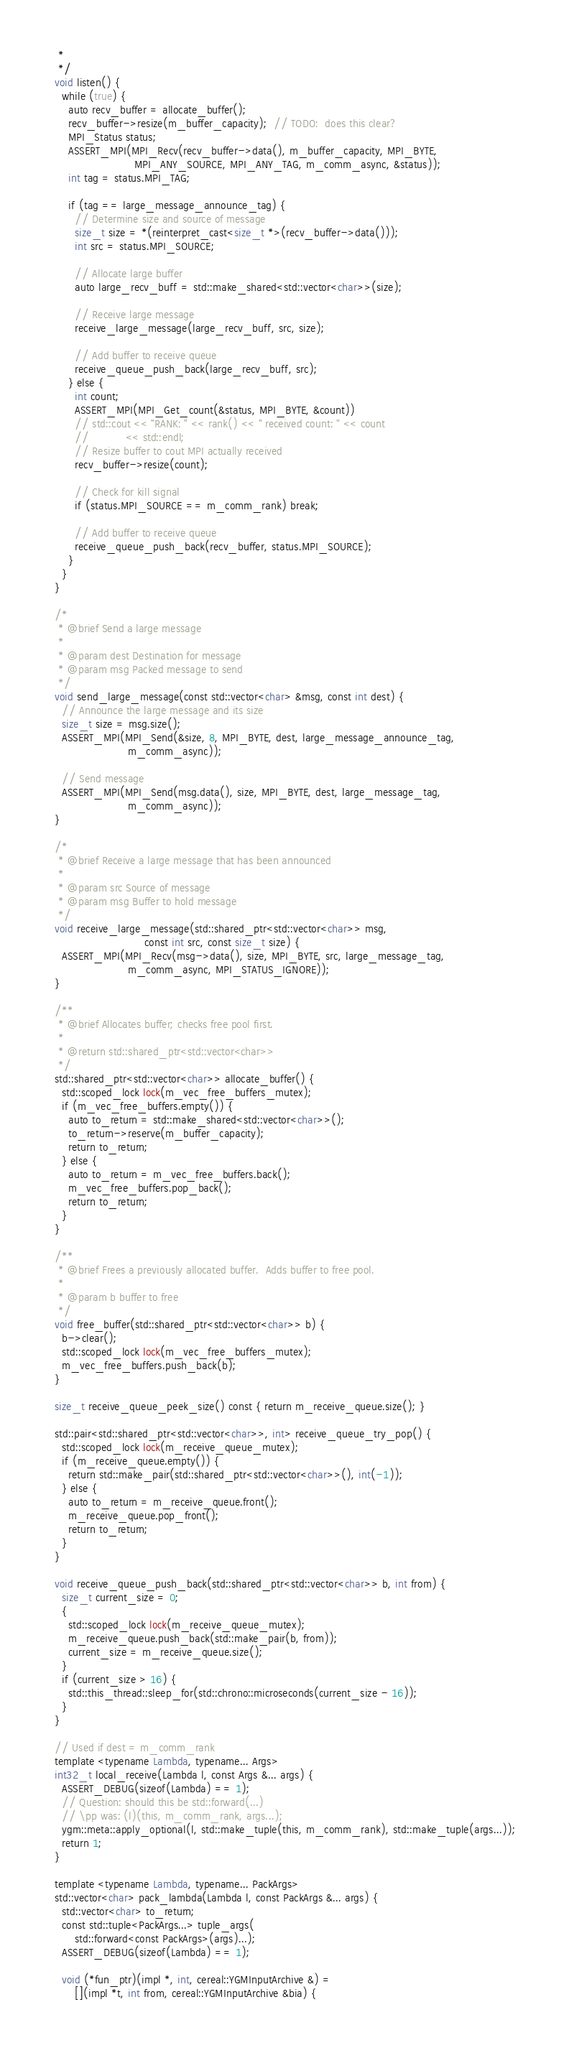<code> <loc_0><loc_0><loc_500><loc_500><_C++_>   *
   */
  void listen() {
    while (true) {
      auto recv_buffer = allocate_buffer();
      recv_buffer->resize(m_buffer_capacity);  // TODO:  does this clear?
      MPI_Status status;
      ASSERT_MPI(MPI_Recv(recv_buffer->data(), m_buffer_capacity, MPI_BYTE,
                          MPI_ANY_SOURCE, MPI_ANY_TAG, m_comm_async, &status));
      int tag = status.MPI_TAG;

      if (tag == large_message_announce_tag) {
        // Determine size and source of message
        size_t size = *(reinterpret_cast<size_t *>(recv_buffer->data()));
        int src = status.MPI_SOURCE;

        // Allocate large buffer
        auto large_recv_buff = std::make_shared<std::vector<char>>(size);

        // Receive large message
        receive_large_message(large_recv_buff, src, size);

        // Add buffer to receive queue
        receive_queue_push_back(large_recv_buff, src);
      } else {
        int count;
        ASSERT_MPI(MPI_Get_count(&status, MPI_BYTE, &count))
        // std::cout << "RANK: " << rank() << " received count: " << count
        //           << std::endl;
        // Resize buffer to cout MPI actually received
        recv_buffer->resize(count);

        // Check for kill signal
        if (status.MPI_SOURCE == m_comm_rank) break;

        // Add buffer to receive queue
        receive_queue_push_back(recv_buffer, status.MPI_SOURCE);
      }
    }
  }

  /*
   * @brief Send a large message
   *
   * @param dest Destination for message
   * @param msg Packed message to send
   */
  void send_large_message(const std::vector<char> &msg, const int dest) {
    // Announce the large message and its size
    size_t size = msg.size();
    ASSERT_MPI(MPI_Send(&size, 8, MPI_BYTE, dest, large_message_announce_tag,
                        m_comm_async));

    // Send message
    ASSERT_MPI(MPI_Send(msg.data(), size, MPI_BYTE, dest, large_message_tag,
                        m_comm_async));
  }

  /*
   * @brief Receive a large message that has been announced
   *
   * @param src Source of message
   * @param msg Buffer to hold message
   */
  void receive_large_message(std::shared_ptr<std::vector<char>> msg,
                             const int src, const size_t size) {
    ASSERT_MPI(MPI_Recv(msg->data(), size, MPI_BYTE, src, large_message_tag,
                        m_comm_async, MPI_STATUS_IGNORE));
  }

  /**
   * @brief Allocates buffer; checks free pool first.
   *
   * @return std::shared_ptr<std::vector<char>>
   */
  std::shared_ptr<std::vector<char>> allocate_buffer() {
    std::scoped_lock lock(m_vec_free_buffers_mutex);
    if (m_vec_free_buffers.empty()) {
      auto to_return = std::make_shared<std::vector<char>>();
      to_return->reserve(m_buffer_capacity);
      return to_return;
    } else {
      auto to_return = m_vec_free_buffers.back();
      m_vec_free_buffers.pop_back();
      return to_return;
    }
  }

  /**
   * @brief Frees a previously allocated buffer.  Adds buffer to free pool.
   *
   * @param b buffer to free
   */
  void free_buffer(std::shared_ptr<std::vector<char>> b) {
    b->clear();
    std::scoped_lock lock(m_vec_free_buffers_mutex);
    m_vec_free_buffers.push_back(b);
  }

  size_t receive_queue_peek_size() const { return m_receive_queue.size(); }

  std::pair<std::shared_ptr<std::vector<char>>, int> receive_queue_try_pop() {
    std::scoped_lock lock(m_receive_queue_mutex);
    if (m_receive_queue.empty()) {
      return std::make_pair(std::shared_ptr<std::vector<char>>(), int(-1));
    } else {
      auto to_return = m_receive_queue.front();
      m_receive_queue.pop_front();
      return to_return;
    }
  }

  void receive_queue_push_back(std::shared_ptr<std::vector<char>> b, int from) {
    size_t current_size = 0;
    {
      std::scoped_lock lock(m_receive_queue_mutex);
      m_receive_queue.push_back(std::make_pair(b, from));
      current_size = m_receive_queue.size();
    }
    if (current_size > 16) {
      std::this_thread::sleep_for(std::chrono::microseconds(current_size - 16));
    }
  }

  // Used if dest = m_comm_rank
  template <typename Lambda, typename... Args>
  int32_t local_receive(Lambda l, const Args &... args) {
    ASSERT_DEBUG(sizeof(Lambda) == 1);
    // Question: should this be std::forward(...)
    // \pp was: (l)(this, m_comm_rank, args...);
    ygm::meta::apply_optional(l, std::make_tuple(this, m_comm_rank), std::make_tuple(args...));
    return 1;
  }

  template <typename Lambda, typename... PackArgs>
  std::vector<char> pack_lambda(Lambda l, const PackArgs &... args) {
    std::vector<char> to_return;
    const std::tuple<PackArgs...> tuple_args(
        std::forward<const PackArgs>(args)...);
    ASSERT_DEBUG(sizeof(Lambda) == 1);

    void (*fun_ptr)(impl *, int, cereal::YGMInputArchive &) =
        [](impl *t, int from, cereal::YGMInputArchive &bia) {</code> 